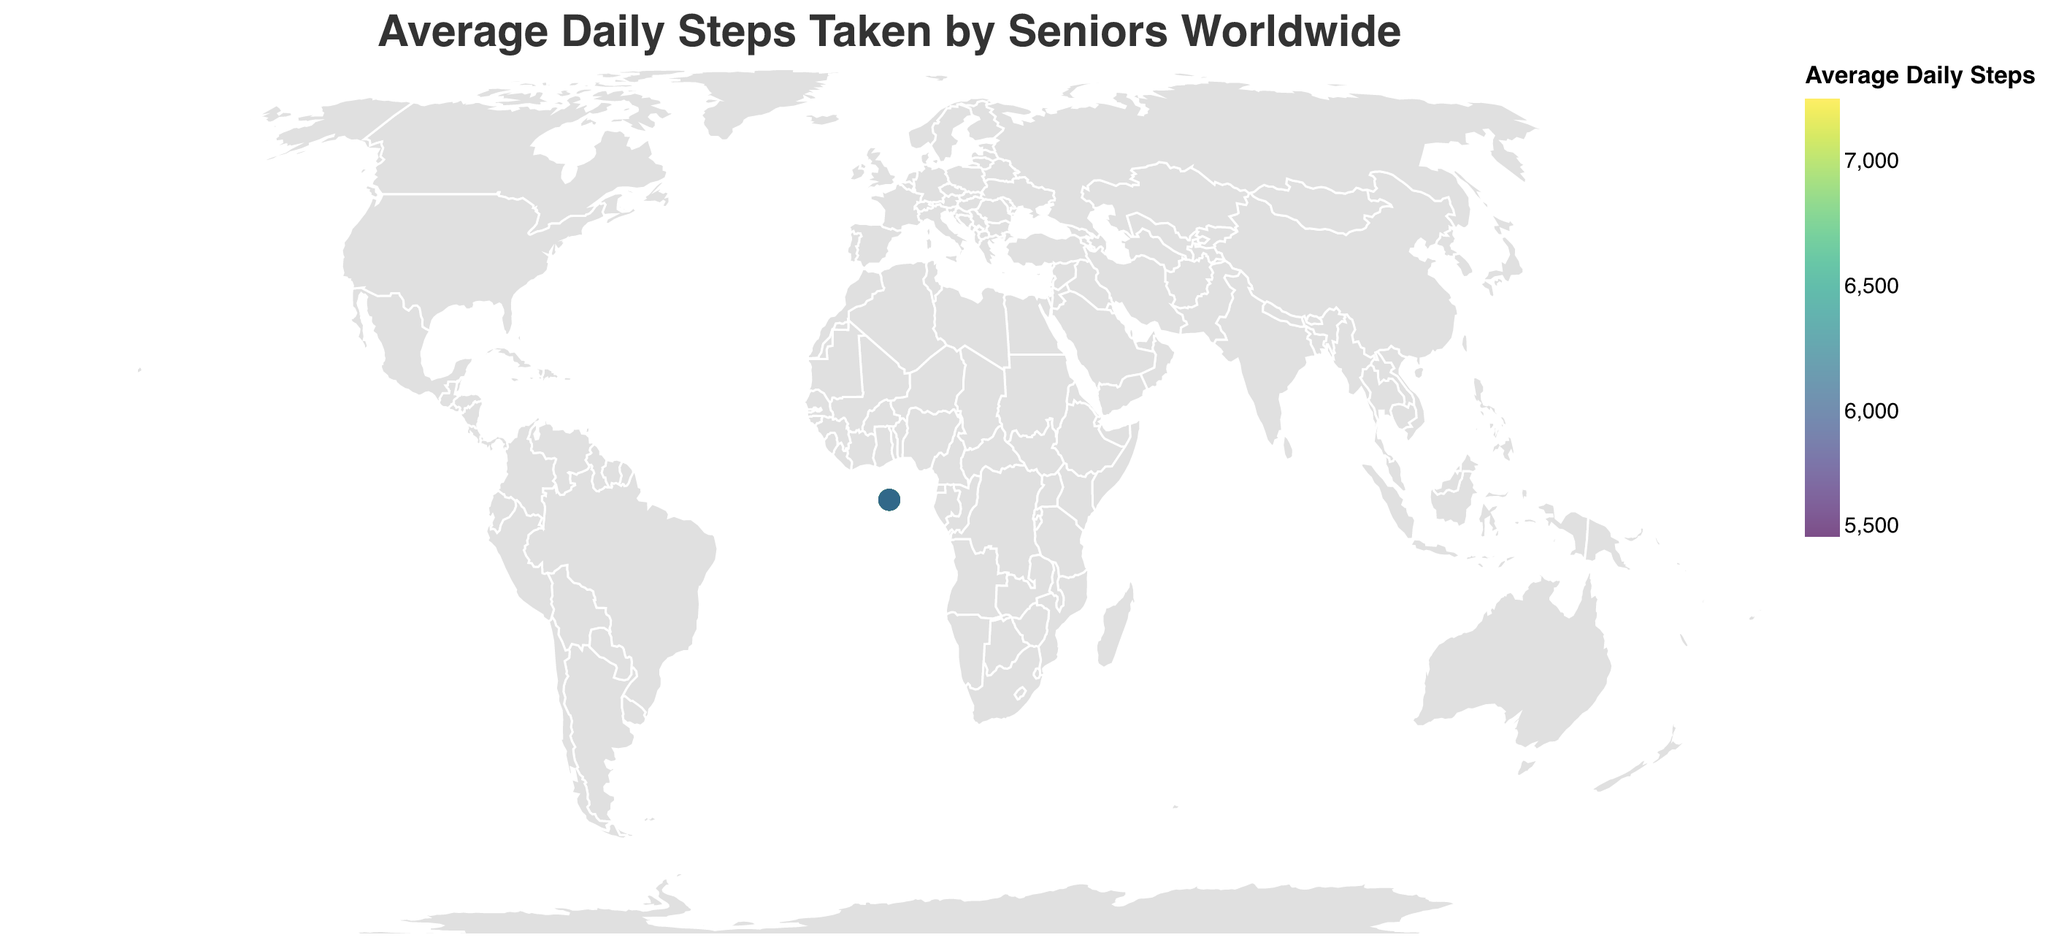What is the title of the figure? The title of the figure is prominently displayed at the top and should be clearly readable.
Answer: "Average Daily Steps Taken by Seniors Worldwide" Which country has the highest average daily steps? The plotted data shows a marker with the highest value on the visualized scale, identifying the peak represented by color intensity.
Answer: Japan Which country has the lowest average daily steps? The plotted data shows a marker with the lowest value on the visualized scale, identifying the minimum value represented by color intensity.
Answer: United States What is the average daily steps value for Switzerland? Look for Switzerland on the plot and refer to its associated data point.
Answer: 7000 How does the average daily steps in Germany compare to that in France? Identify the data points for Germany and France and compare their average daily steps values.
Answer: Germany has higher average daily steps (6800) compared to France (6400) What is the range of the average daily steps across the countries? The range is found by subtracting the smallest value (United States, 5500) from the largest value (Japan, 7250).
Answer: 1750 Which three countries have the closest average daily steps values to each other? Identify countries with step counts that are numerically close to each other.
Answer: New Zealand (6300), Spain (6300), and Belgium (6200) How many countries have average daily steps above 6500? Count the number of data points where the average daily steps are greater than 6500.
Answer: 7 What's the median of the average daily steps values across all countries? List all the average daily steps values, order them, and find the middle value. With an even number of observations (20 countries), the median is the average of the 10th and 11th values when sorted.
Answer: (6300 + 6400) / 2 = 6350 Which countries belong to the top 25% in terms of average daily steps? Order all countries by average daily steps and select the top quartile (5 highest values out of 20 countries).
Answer: Japan, Sweden, Netherlands, South Korea, Switzerland 